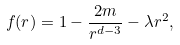<formula> <loc_0><loc_0><loc_500><loc_500>f ( r ) = 1 - \frac { 2 m } { r ^ { d - 3 } } - \lambda r ^ { 2 } ,</formula> 